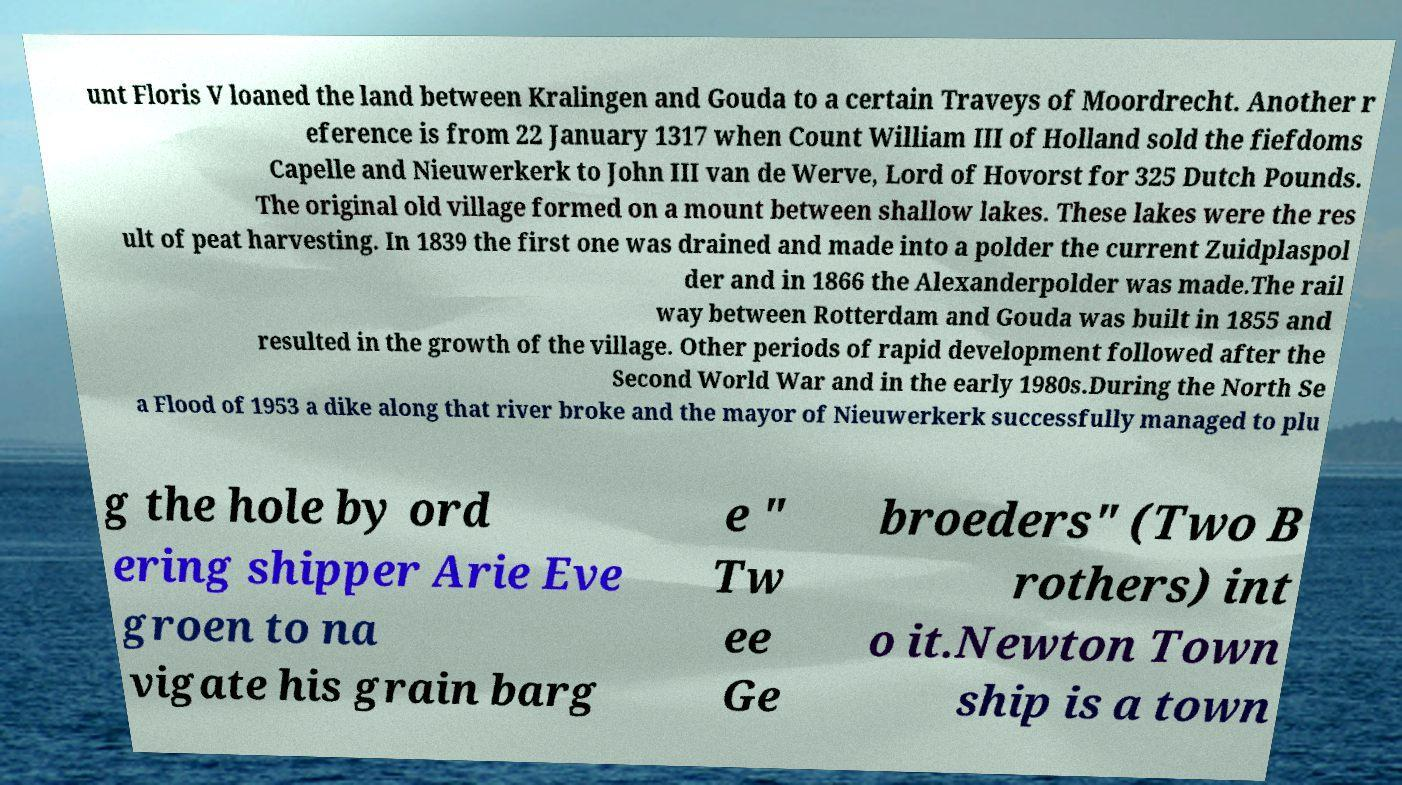Could you extract and type out the text from this image? unt Floris V loaned the land between Kralingen and Gouda to a certain Traveys of Moordrecht. Another r eference is from 22 January 1317 when Count William III of Holland sold the fiefdoms Capelle and Nieuwerkerk to John III van de Werve, Lord of Hovorst for 325 Dutch Pounds. The original old village formed on a mount between shallow lakes. These lakes were the res ult of peat harvesting. In 1839 the first one was drained and made into a polder the current Zuidplaspol der and in 1866 the Alexanderpolder was made.The rail way between Rotterdam and Gouda was built in 1855 and resulted in the growth of the village. Other periods of rapid development followed after the Second World War and in the early 1980s.During the North Se a Flood of 1953 a dike along that river broke and the mayor of Nieuwerkerk successfully managed to plu g the hole by ord ering shipper Arie Eve groen to na vigate his grain barg e " Tw ee Ge broeders" (Two B rothers) int o it.Newton Town ship is a town 